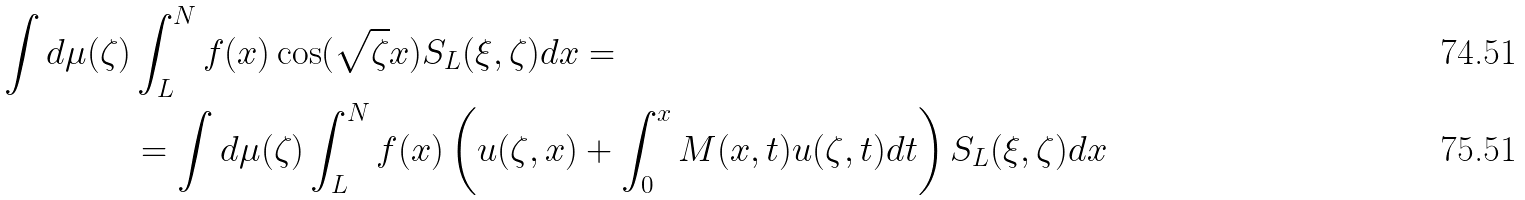<formula> <loc_0><loc_0><loc_500><loc_500>\int d \mu ( \zeta ) & \int _ { L } ^ { N } f ( x ) \cos ( \sqrt { \zeta } x ) S _ { L } ( \xi , \zeta ) d x = \\ & = \int d \mu ( \zeta ) \int _ { L } ^ { N } f ( x ) \left ( u ( \zeta , x ) + \int _ { 0 } ^ { x } M ( x , t ) u ( \zeta , t ) d t \right ) S _ { L } ( \xi , \zeta ) d x</formula> 